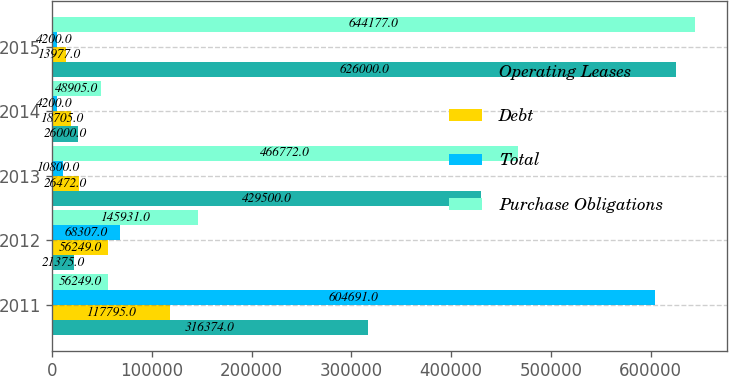<chart> <loc_0><loc_0><loc_500><loc_500><stacked_bar_chart><ecel><fcel>2011<fcel>2012<fcel>2013<fcel>2014<fcel>2015<nl><fcel>Operating Leases<fcel>316374<fcel>21375<fcel>429500<fcel>26000<fcel>626000<nl><fcel>Debt<fcel>117795<fcel>56249<fcel>26472<fcel>18705<fcel>13977<nl><fcel>Total<fcel>604691<fcel>68307<fcel>10800<fcel>4200<fcel>4200<nl><fcel>Purchase Obligations<fcel>56249<fcel>145931<fcel>466772<fcel>48905<fcel>644177<nl></chart> 